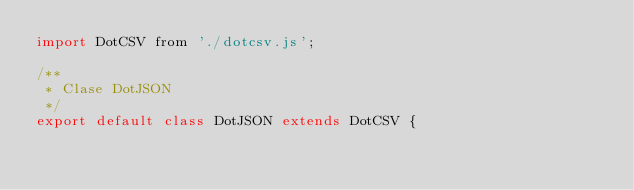<code> <loc_0><loc_0><loc_500><loc_500><_JavaScript_>import DotCSV from './dotcsv.js';

/**
 * Clase DotJSON
 */
export default class DotJSON extends DotCSV {</code> 